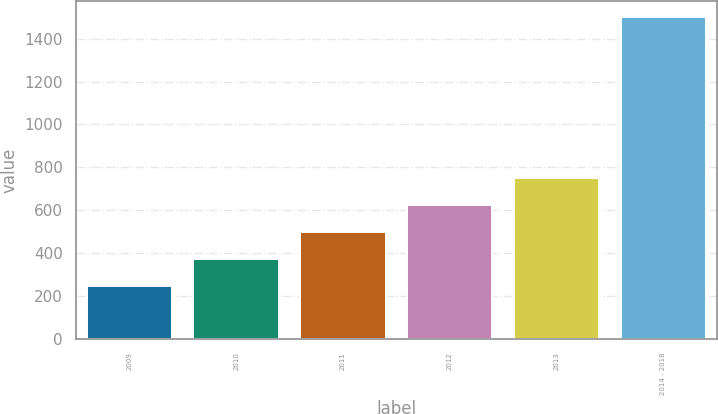<chart> <loc_0><loc_0><loc_500><loc_500><bar_chart><fcel>2009<fcel>2010<fcel>2011<fcel>2012<fcel>2013<fcel>2014 - 2018<nl><fcel>247<fcel>372.2<fcel>497.4<fcel>622.6<fcel>747.8<fcel>1499<nl></chart> 